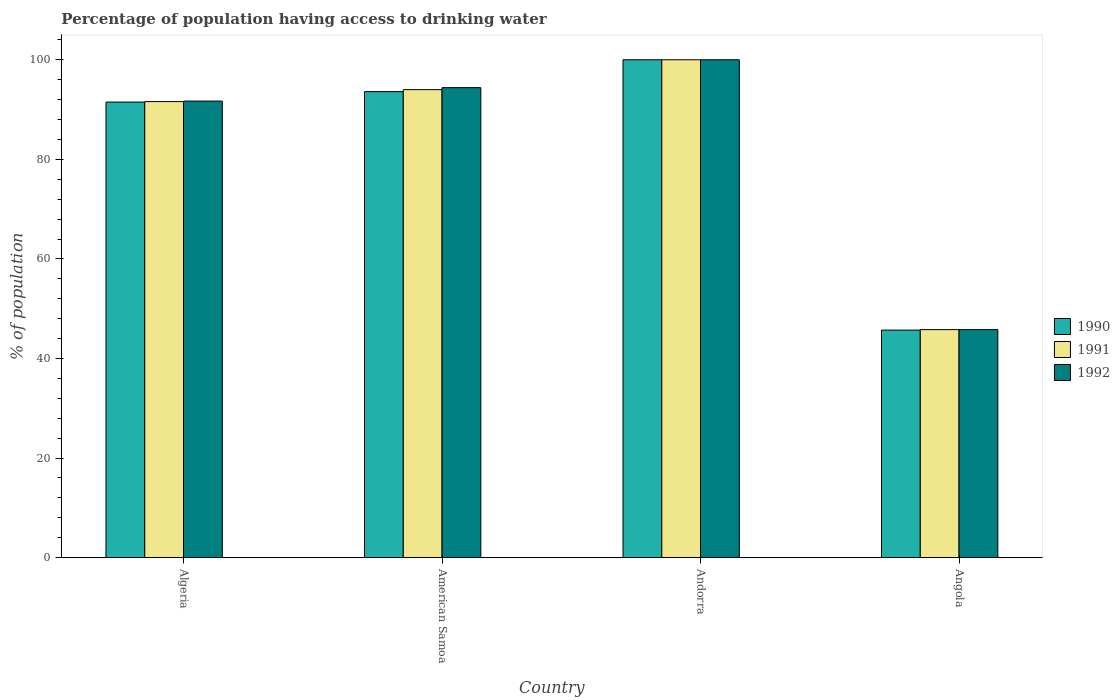How many different coloured bars are there?
Provide a succinct answer. 3. How many bars are there on the 4th tick from the left?
Give a very brief answer. 3. What is the label of the 4th group of bars from the left?
Provide a succinct answer. Angola. In how many cases, is the number of bars for a given country not equal to the number of legend labels?
Offer a terse response. 0. Across all countries, what is the maximum percentage of population having access to drinking water in 1992?
Your answer should be very brief. 100. Across all countries, what is the minimum percentage of population having access to drinking water in 1992?
Ensure brevity in your answer.  45.8. In which country was the percentage of population having access to drinking water in 1992 maximum?
Make the answer very short. Andorra. In which country was the percentage of population having access to drinking water in 1991 minimum?
Offer a very short reply. Angola. What is the total percentage of population having access to drinking water in 1992 in the graph?
Your answer should be very brief. 331.9. What is the difference between the percentage of population having access to drinking water in 1990 in Algeria and that in Andorra?
Your response must be concise. -8.5. What is the difference between the percentage of population having access to drinking water in 1990 in Angola and the percentage of population having access to drinking water in 1991 in American Samoa?
Offer a terse response. -48.3. What is the average percentage of population having access to drinking water in 1992 per country?
Provide a short and direct response. 82.98. What is the difference between the percentage of population having access to drinking water of/in 1990 and percentage of population having access to drinking water of/in 1992 in Angola?
Make the answer very short. -0.1. In how many countries, is the percentage of population having access to drinking water in 1991 greater than 24 %?
Give a very brief answer. 4. What is the ratio of the percentage of population having access to drinking water in 1990 in Andorra to that in Angola?
Give a very brief answer. 2.19. Is the percentage of population having access to drinking water in 1992 in American Samoa less than that in Andorra?
Ensure brevity in your answer.  Yes. Is the difference between the percentage of population having access to drinking water in 1990 in American Samoa and Andorra greater than the difference between the percentage of population having access to drinking water in 1992 in American Samoa and Andorra?
Keep it short and to the point. No. What is the difference between the highest and the second highest percentage of population having access to drinking water in 1991?
Give a very brief answer. -8.4. What is the difference between the highest and the lowest percentage of population having access to drinking water in 1992?
Your answer should be very brief. 54.2. In how many countries, is the percentage of population having access to drinking water in 1992 greater than the average percentage of population having access to drinking water in 1992 taken over all countries?
Make the answer very short. 3. What does the 2nd bar from the left in Angola represents?
Make the answer very short. 1991. How many bars are there?
Make the answer very short. 12. How many countries are there in the graph?
Provide a short and direct response. 4. Are the values on the major ticks of Y-axis written in scientific E-notation?
Give a very brief answer. No. Does the graph contain any zero values?
Make the answer very short. No. Does the graph contain grids?
Keep it short and to the point. No. Where does the legend appear in the graph?
Your answer should be very brief. Center right. What is the title of the graph?
Your response must be concise. Percentage of population having access to drinking water. Does "1985" appear as one of the legend labels in the graph?
Give a very brief answer. No. What is the label or title of the Y-axis?
Keep it short and to the point. % of population. What is the % of population in 1990 in Algeria?
Provide a short and direct response. 91.5. What is the % of population of 1991 in Algeria?
Give a very brief answer. 91.6. What is the % of population in 1992 in Algeria?
Make the answer very short. 91.7. What is the % of population of 1990 in American Samoa?
Offer a terse response. 93.6. What is the % of population in 1991 in American Samoa?
Offer a terse response. 94. What is the % of population in 1992 in American Samoa?
Ensure brevity in your answer.  94.4. What is the % of population in 1990 in Angola?
Ensure brevity in your answer.  45.7. What is the % of population of 1991 in Angola?
Your answer should be very brief. 45.8. What is the % of population in 1992 in Angola?
Give a very brief answer. 45.8. Across all countries, what is the maximum % of population in 1990?
Make the answer very short. 100. Across all countries, what is the maximum % of population in 1991?
Provide a short and direct response. 100. Across all countries, what is the minimum % of population in 1990?
Offer a very short reply. 45.7. Across all countries, what is the minimum % of population in 1991?
Keep it short and to the point. 45.8. Across all countries, what is the minimum % of population in 1992?
Give a very brief answer. 45.8. What is the total % of population in 1990 in the graph?
Offer a very short reply. 330.8. What is the total % of population in 1991 in the graph?
Your answer should be very brief. 331.4. What is the total % of population in 1992 in the graph?
Your answer should be compact. 331.9. What is the difference between the % of population of 1991 in Algeria and that in American Samoa?
Offer a terse response. -2.4. What is the difference between the % of population of 1990 in Algeria and that in Andorra?
Give a very brief answer. -8.5. What is the difference between the % of population in 1991 in Algeria and that in Andorra?
Provide a short and direct response. -8.4. What is the difference between the % of population in 1990 in Algeria and that in Angola?
Keep it short and to the point. 45.8. What is the difference between the % of population of 1991 in Algeria and that in Angola?
Provide a short and direct response. 45.8. What is the difference between the % of population in 1992 in Algeria and that in Angola?
Your answer should be very brief. 45.9. What is the difference between the % of population in 1990 in American Samoa and that in Angola?
Offer a terse response. 47.9. What is the difference between the % of population in 1991 in American Samoa and that in Angola?
Offer a terse response. 48.2. What is the difference between the % of population of 1992 in American Samoa and that in Angola?
Keep it short and to the point. 48.6. What is the difference between the % of population in 1990 in Andorra and that in Angola?
Offer a very short reply. 54.3. What is the difference between the % of population in 1991 in Andorra and that in Angola?
Your answer should be compact. 54.2. What is the difference between the % of population of 1992 in Andorra and that in Angola?
Keep it short and to the point. 54.2. What is the difference between the % of population of 1991 in Algeria and the % of population of 1992 in American Samoa?
Provide a succinct answer. -2.8. What is the difference between the % of population in 1990 in Algeria and the % of population in 1991 in Andorra?
Keep it short and to the point. -8.5. What is the difference between the % of population in 1990 in Algeria and the % of population in 1991 in Angola?
Offer a terse response. 45.7. What is the difference between the % of population of 1990 in Algeria and the % of population of 1992 in Angola?
Ensure brevity in your answer.  45.7. What is the difference between the % of population of 1991 in Algeria and the % of population of 1992 in Angola?
Keep it short and to the point. 45.8. What is the difference between the % of population in 1990 in American Samoa and the % of population in 1991 in Andorra?
Provide a succinct answer. -6.4. What is the difference between the % of population in 1991 in American Samoa and the % of population in 1992 in Andorra?
Your answer should be compact. -6. What is the difference between the % of population of 1990 in American Samoa and the % of population of 1991 in Angola?
Make the answer very short. 47.8. What is the difference between the % of population of 1990 in American Samoa and the % of population of 1992 in Angola?
Provide a short and direct response. 47.8. What is the difference between the % of population in 1991 in American Samoa and the % of population in 1992 in Angola?
Your response must be concise. 48.2. What is the difference between the % of population of 1990 in Andorra and the % of population of 1991 in Angola?
Ensure brevity in your answer.  54.2. What is the difference between the % of population in 1990 in Andorra and the % of population in 1992 in Angola?
Offer a very short reply. 54.2. What is the difference between the % of population of 1991 in Andorra and the % of population of 1992 in Angola?
Your response must be concise. 54.2. What is the average % of population in 1990 per country?
Provide a succinct answer. 82.7. What is the average % of population in 1991 per country?
Ensure brevity in your answer.  82.85. What is the average % of population of 1992 per country?
Ensure brevity in your answer.  82.97. What is the difference between the % of population in 1990 and % of population in 1991 in Algeria?
Offer a terse response. -0.1. What is the difference between the % of population in 1990 and % of population in 1992 in Algeria?
Your response must be concise. -0.2. What is the difference between the % of population in 1991 and % of population in 1992 in Algeria?
Give a very brief answer. -0.1. What is the difference between the % of population in 1990 and % of population in 1991 in American Samoa?
Ensure brevity in your answer.  -0.4. What is the difference between the % of population of 1990 and % of population of 1992 in American Samoa?
Provide a short and direct response. -0.8. What is the difference between the % of population of 1991 and % of population of 1992 in American Samoa?
Offer a terse response. -0.4. What is the difference between the % of population of 1991 and % of population of 1992 in Andorra?
Your response must be concise. 0. What is the difference between the % of population in 1990 and % of population in 1992 in Angola?
Offer a very short reply. -0.1. What is the ratio of the % of population of 1990 in Algeria to that in American Samoa?
Your answer should be very brief. 0.98. What is the ratio of the % of population in 1991 in Algeria to that in American Samoa?
Keep it short and to the point. 0.97. What is the ratio of the % of population of 1992 in Algeria to that in American Samoa?
Keep it short and to the point. 0.97. What is the ratio of the % of population of 1990 in Algeria to that in Andorra?
Your answer should be compact. 0.92. What is the ratio of the % of population in 1991 in Algeria to that in Andorra?
Make the answer very short. 0.92. What is the ratio of the % of population in 1992 in Algeria to that in Andorra?
Give a very brief answer. 0.92. What is the ratio of the % of population of 1990 in Algeria to that in Angola?
Keep it short and to the point. 2. What is the ratio of the % of population of 1992 in Algeria to that in Angola?
Provide a succinct answer. 2. What is the ratio of the % of population of 1990 in American Samoa to that in Andorra?
Ensure brevity in your answer.  0.94. What is the ratio of the % of population in 1991 in American Samoa to that in Andorra?
Make the answer very short. 0.94. What is the ratio of the % of population of 1992 in American Samoa to that in Andorra?
Make the answer very short. 0.94. What is the ratio of the % of population of 1990 in American Samoa to that in Angola?
Your response must be concise. 2.05. What is the ratio of the % of population in 1991 in American Samoa to that in Angola?
Ensure brevity in your answer.  2.05. What is the ratio of the % of population of 1992 in American Samoa to that in Angola?
Your answer should be compact. 2.06. What is the ratio of the % of population of 1990 in Andorra to that in Angola?
Offer a very short reply. 2.19. What is the ratio of the % of population in 1991 in Andorra to that in Angola?
Provide a succinct answer. 2.18. What is the ratio of the % of population of 1992 in Andorra to that in Angola?
Make the answer very short. 2.18. What is the difference between the highest and the second highest % of population in 1990?
Your answer should be very brief. 6.4. What is the difference between the highest and the second highest % of population in 1991?
Offer a terse response. 6. What is the difference between the highest and the lowest % of population in 1990?
Provide a short and direct response. 54.3. What is the difference between the highest and the lowest % of population in 1991?
Make the answer very short. 54.2. What is the difference between the highest and the lowest % of population of 1992?
Provide a succinct answer. 54.2. 